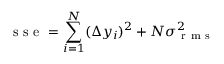<formula> <loc_0><loc_0><loc_500><loc_500>s s e = \sum _ { i = 1 } ^ { N } ( \Delta y _ { i } ) ^ { 2 } + N \sigma _ { r m s } ^ { 2 }</formula> 